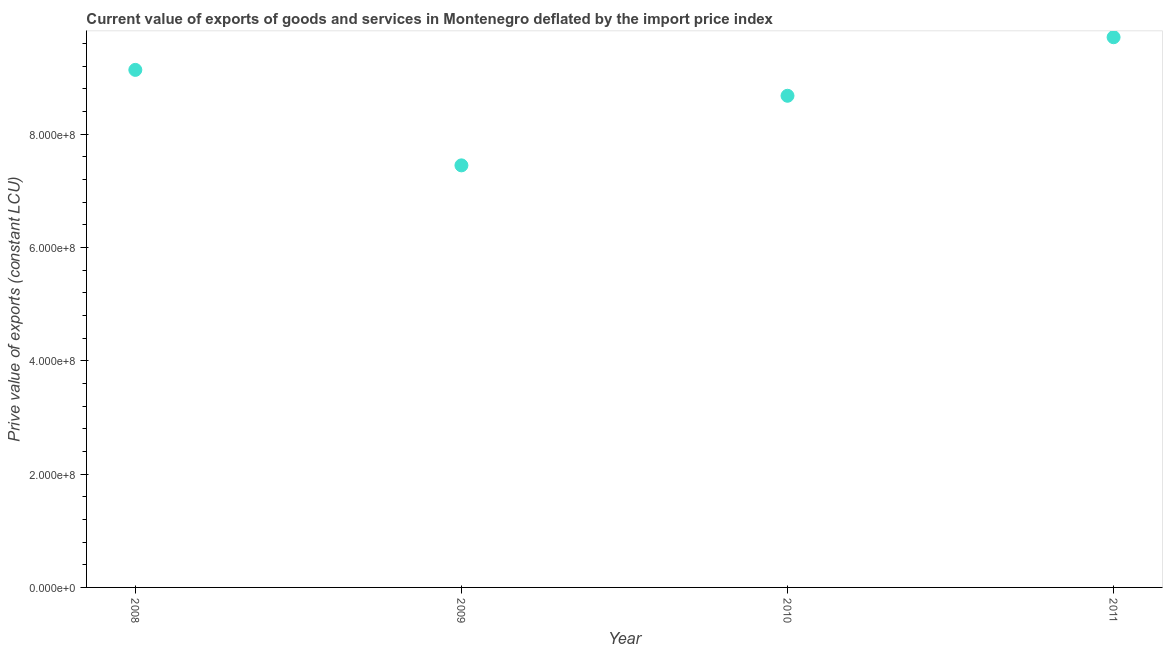What is the price value of exports in 2010?
Offer a terse response. 8.68e+08. Across all years, what is the maximum price value of exports?
Provide a short and direct response. 9.71e+08. Across all years, what is the minimum price value of exports?
Your answer should be compact. 7.45e+08. What is the sum of the price value of exports?
Provide a succinct answer. 3.50e+09. What is the difference between the price value of exports in 2009 and 2010?
Ensure brevity in your answer.  -1.23e+08. What is the average price value of exports per year?
Ensure brevity in your answer.  8.74e+08. What is the median price value of exports?
Make the answer very short. 8.90e+08. In how many years, is the price value of exports greater than 200000000 LCU?
Make the answer very short. 4. Do a majority of the years between 2009 and 2010 (inclusive) have price value of exports greater than 800000000 LCU?
Offer a terse response. No. What is the ratio of the price value of exports in 2010 to that in 2011?
Ensure brevity in your answer.  0.89. Is the difference between the price value of exports in 2008 and 2010 greater than the difference between any two years?
Provide a succinct answer. No. What is the difference between the highest and the second highest price value of exports?
Make the answer very short. 5.76e+07. Is the sum of the price value of exports in 2008 and 2009 greater than the maximum price value of exports across all years?
Keep it short and to the point. Yes. What is the difference between the highest and the lowest price value of exports?
Keep it short and to the point. 2.26e+08. In how many years, is the price value of exports greater than the average price value of exports taken over all years?
Provide a short and direct response. 2. Does the price value of exports monotonically increase over the years?
Provide a short and direct response. No. How many dotlines are there?
Provide a succinct answer. 1. Are the values on the major ticks of Y-axis written in scientific E-notation?
Your answer should be compact. Yes. Does the graph contain any zero values?
Make the answer very short. No. Does the graph contain grids?
Keep it short and to the point. No. What is the title of the graph?
Your answer should be compact. Current value of exports of goods and services in Montenegro deflated by the import price index. What is the label or title of the Y-axis?
Keep it short and to the point. Prive value of exports (constant LCU). What is the Prive value of exports (constant LCU) in 2008?
Give a very brief answer. 9.13e+08. What is the Prive value of exports (constant LCU) in 2009?
Give a very brief answer. 7.45e+08. What is the Prive value of exports (constant LCU) in 2010?
Provide a succinct answer. 8.68e+08. What is the Prive value of exports (constant LCU) in 2011?
Provide a succinct answer. 9.71e+08. What is the difference between the Prive value of exports (constant LCU) in 2008 and 2009?
Keep it short and to the point. 1.68e+08. What is the difference between the Prive value of exports (constant LCU) in 2008 and 2010?
Provide a short and direct response. 4.57e+07. What is the difference between the Prive value of exports (constant LCU) in 2008 and 2011?
Provide a short and direct response. -5.76e+07. What is the difference between the Prive value of exports (constant LCU) in 2009 and 2010?
Your answer should be compact. -1.23e+08. What is the difference between the Prive value of exports (constant LCU) in 2009 and 2011?
Make the answer very short. -2.26e+08. What is the difference between the Prive value of exports (constant LCU) in 2010 and 2011?
Provide a succinct answer. -1.03e+08. What is the ratio of the Prive value of exports (constant LCU) in 2008 to that in 2009?
Your answer should be very brief. 1.23. What is the ratio of the Prive value of exports (constant LCU) in 2008 to that in 2010?
Your answer should be compact. 1.05. What is the ratio of the Prive value of exports (constant LCU) in 2008 to that in 2011?
Your response must be concise. 0.94. What is the ratio of the Prive value of exports (constant LCU) in 2009 to that in 2010?
Your answer should be compact. 0.86. What is the ratio of the Prive value of exports (constant LCU) in 2009 to that in 2011?
Your answer should be compact. 0.77. What is the ratio of the Prive value of exports (constant LCU) in 2010 to that in 2011?
Ensure brevity in your answer.  0.89. 